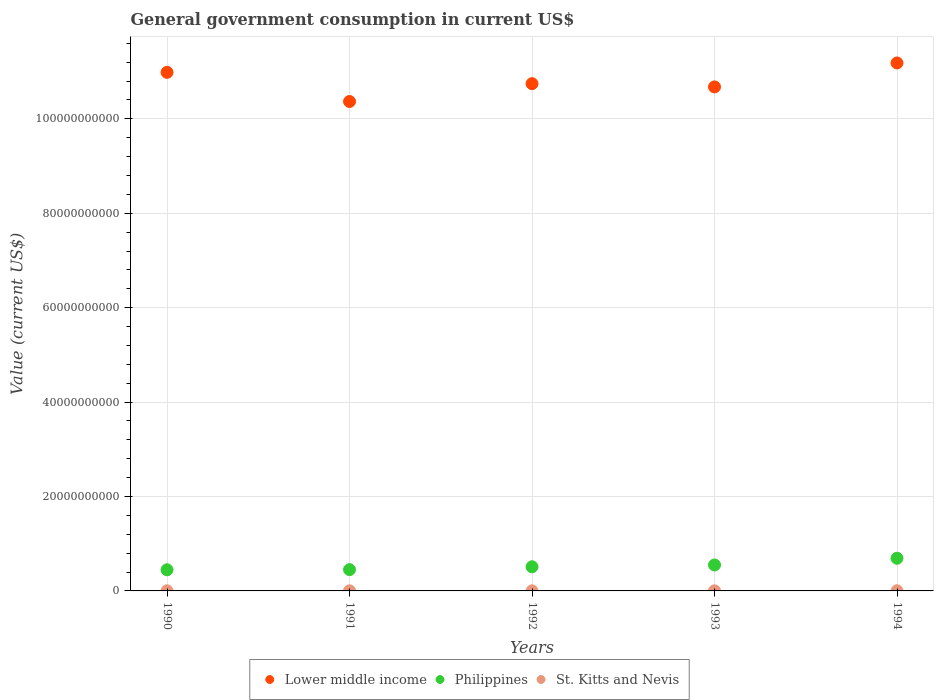How many different coloured dotlines are there?
Provide a short and direct response. 3. What is the government conusmption in Lower middle income in 1991?
Provide a short and direct response. 1.04e+11. Across all years, what is the maximum government conusmption in Lower middle income?
Provide a short and direct response. 1.12e+11. Across all years, what is the minimum government conusmption in Philippines?
Your answer should be very brief. 4.48e+09. In which year was the government conusmption in Philippines maximum?
Provide a short and direct response. 1994. In which year was the government conusmption in Philippines minimum?
Give a very brief answer. 1990. What is the total government conusmption in Lower middle income in the graph?
Make the answer very short. 5.40e+11. What is the difference between the government conusmption in Philippines in 1990 and that in 1994?
Your answer should be very brief. -2.44e+09. What is the difference between the government conusmption in St. Kitts and Nevis in 1993 and the government conusmption in Philippines in 1990?
Keep it short and to the point. -4.45e+09. What is the average government conusmption in Philippines per year?
Keep it short and to the point. 5.30e+09. In the year 1994, what is the difference between the government conusmption in St. Kitts and Nevis and government conusmption in Lower middle income?
Make the answer very short. -1.12e+11. What is the ratio of the government conusmption in Lower middle income in 1990 to that in 1994?
Provide a succinct answer. 0.98. Is the difference between the government conusmption in St. Kitts and Nevis in 1992 and 1994 greater than the difference between the government conusmption in Lower middle income in 1992 and 1994?
Keep it short and to the point. Yes. What is the difference between the highest and the second highest government conusmption in Lower middle income?
Keep it short and to the point. 1.99e+09. What is the difference between the highest and the lowest government conusmption in Lower middle income?
Offer a very short reply. 8.16e+09. In how many years, is the government conusmption in Lower middle income greater than the average government conusmption in Lower middle income taken over all years?
Your answer should be very brief. 2. Is it the case that in every year, the sum of the government conusmption in Philippines and government conusmption in Lower middle income  is greater than the government conusmption in St. Kitts and Nevis?
Ensure brevity in your answer.  Yes. Does the government conusmption in Lower middle income monotonically increase over the years?
Provide a succinct answer. No. Is the government conusmption in Lower middle income strictly less than the government conusmption in Philippines over the years?
Your response must be concise. No. How many years are there in the graph?
Your response must be concise. 5. What is the difference between two consecutive major ticks on the Y-axis?
Ensure brevity in your answer.  2.00e+1. Are the values on the major ticks of Y-axis written in scientific E-notation?
Keep it short and to the point. No. What is the title of the graph?
Give a very brief answer. General government consumption in current US$. What is the label or title of the X-axis?
Ensure brevity in your answer.  Years. What is the label or title of the Y-axis?
Give a very brief answer. Value (current US$). What is the Value (current US$) of Lower middle income in 1990?
Give a very brief answer. 1.10e+11. What is the Value (current US$) of Philippines in 1990?
Offer a very short reply. 4.48e+09. What is the Value (current US$) of St. Kitts and Nevis in 1990?
Give a very brief answer. 2.09e+07. What is the Value (current US$) of Lower middle income in 1991?
Your response must be concise. 1.04e+11. What is the Value (current US$) of Philippines in 1991?
Your response must be concise. 4.51e+09. What is the Value (current US$) of St. Kitts and Nevis in 1991?
Give a very brief answer. 2.08e+07. What is the Value (current US$) in Lower middle income in 1992?
Your answer should be very brief. 1.07e+11. What is the Value (current US$) of Philippines in 1992?
Give a very brief answer. 5.12e+09. What is the Value (current US$) of St. Kitts and Nevis in 1992?
Ensure brevity in your answer.  2.32e+07. What is the Value (current US$) in Lower middle income in 1993?
Make the answer very short. 1.07e+11. What is the Value (current US$) in Philippines in 1993?
Offer a very short reply. 5.50e+09. What is the Value (current US$) in St. Kitts and Nevis in 1993?
Give a very brief answer. 2.53e+07. What is the Value (current US$) in Lower middle income in 1994?
Your response must be concise. 1.12e+11. What is the Value (current US$) in Philippines in 1994?
Make the answer very short. 6.92e+09. What is the Value (current US$) in St. Kitts and Nevis in 1994?
Ensure brevity in your answer.  3.22e+07. Across all years, what is the maximum Value (current US$) of Lower middle income?
Give a very brief answer. 1.12e+11. Across all years, what is the maximum Value (current US$) of Philippines?
Give a very brief answer. 6.92e+09. Across all years, what is the maximum Value (current US$) in St. Kitts and Nevis?
Your answer should be compact. 3.22e+07. Across all years, what is the minimum Value (current US$) of Lower middle income?
Your response must be concise. 1.04e+11. Across all years, what is the minimum Value (current US$) of Philippines?
Your answer should be very brief. 4.48e+09. Across all years, what is the minimum Value (current US$) of St. Kitts and Nevis?
Give a very brief answer. 2.08e+07. What is the total Value (current US$) of Lower middle income in the graph?
Keep it short and to the point. 5.40e+11. What is the total Value (current US$) in Philippines in the graph?
Provide a short and direct response. 2.65e+1. What is the total Value (current US$) in St. Kitts and Nevis in the graph?
Your answer should be very brief. 1.22e+08. What is the difference between the Value (current US$) in Lower middle income in 1990 and that in 1991?
Offer a very short reply. 6.18e+09. What is the difference between the Value (current US$) of Philippines in 1990 and that in 1991?
Offer a very short reply. -3.12e+07. What is the difference between the Value (current US$) of St. Kitts and Nevis in 1990 and that in 1991?
Your answer should be compact. 1.52e+05. What is the difference between the Value (current US$) in Lower middle income in 1990 and that in 1992?
Provide a short and direct response. 2.40e+09. What is the difference between the Value (current US$) in Philippines in 1990 and that in 1992?
Your answer should be very brief. -6.39e+08. What is the difference between the Value (current US$) in St. Kitts and Nevis in 1990 and that in 1992?
Your answer should be compact. -2.34e+06. What is the difference between the Value (current US$) of Lower middle income in 1990 and that in 1993?
Your answer should be very brief. 3.09e+09. What is the difference between the Value (current US$) of Philippines in 1990 and that in 1993?
Your response must be concise. -1.02e+09. What is the difference between the Value (current US$) in St. Kitts and Nevis in 1990 and that in 1993?
Your answer should be very brief. -4.39e+06. What is the difference between the Value (current US$) in Lower middle income in 1990 and that in 1994?
Give a very brief answer. -1.99e+09. What is the difference between the Value (current US$) in Philippines in 1990 and that in 1994?
Provide a short and direct response. -2.44e+09. What is the difference between the Value (current US$) in St. Kitts and Nevis in 1990 and that in 1994?
Your answer should be compact. -1.13e+07. What is the difference between the Value (current US$) in Lower middle income in 1991 and that in 1992?
Offer a very short reply. -3.78e+09. What is the difference between the Value (current US$) of Philippines in 1991 and that in 1992?
Provide a short and direct response. -6.08e+08. What is the difference between the Value (current US$) of St. Kitts and Nevis in 1991 and that in 1992?
Offer a terse response. -2.49e+06. What is the difference between the Value (current US$) of Lower middle income in 1991 and that in 1993?
Ensure brevity in your answer.  -3.09e+09. What is the difference between the Value (current US$) in Philippines in 1991 and that in 1993?
Give a very brief answer. -9.88e+08. What is the difference between the Value (current US$) of St. Kitts and Nevis in 1991 and that in 1993?
Offer a terse response. -4.54e+06. What is the difference between the Value (current US$) in Lower middle income in 1991 and that in 1994?
Offer a very short reply. -8.16e+09. What is the difference between the Value (current US$) of Philippines in 1991 and that in 1994?
Your answer should be very brief. -2.41e+09. What is the difference between the Value (current US$) of St. Kitts and Nevis in 1991 and that in 1994?
Offer a terse response. -1.15e+07. What is the difference between the Value (current US$) of Lower middle income in 1992 and that in 1993?
Offer a terse response. 6.90e+08. What is the difference between the Value (current US$) in Philippines in 1992 and that in 1993?
Provide a short and direct response. -3.80e+08. What is the difference between the Value (current US$) of St. Kitts and Nevis in 1992 and that in 1993?
Give a very brief answer. -2.05e+06. What is the difference between the Value (current US$) in Lower middle income in 1992 and that in 1994?
Keep it short and to the point. -4.38e+09. What is the difference between the Value (current US$) in Philippines in 1992 and that in 1994?
Make the answer very short. -1.80e+09. What is the difference between the Value (current US$) in St. Kitts and Nevis in 1992 and that in 1994?
Provide a succinct answer. -8.97e+06. What is the difference between the Value (current US$) of Lower middle income in 1993 and that in 1994?
Your response must be concise. -5.07e+09. What is the difference between the Value (current US$) in Philippines in 1993 and that in 1994?
Provide a succinct answer. -1.42e+09. What is the difference between the Value (current US$) in St. Kitts and Nevis in 1993 and that in 1994?
Offer a very short reply. -6.92e+06. What is the difference between the Value (current US$) of Lower middle income in 1990 and the Value (current US$) of Philippines in 1991?
Make the answer very short. 1.05e+11. What is the difference between the Value (current US$) in Lower middle income in 1990 and the Value (current US$) in St. Kitts and Nevis in 1991?
Provide a succinct answer. 1.10e+11. What is the difference between the Value (current US$) of Philippines in 1990 and the Value (current US$) of St. Kitts and Nevis in 1991?
Make the answer very short. 4.46e+09. What is the difference between the Value (current US$) in Lower middle income in 1990 and the Value (current US$) in Philippines in 1992?
Keep it short and to the point. 1.05e+11. What is the difference between the Value (current US$) in Lower middle income in 1990 and the Value (current US$) in St. Kitts and Nevis in 1992?
Your answer should be compact. 1.10e+11. What is the difference between the Value (current US$) of Philippines in 1990 and the Value (current US$) of St. Kitts and Nevis in 1992?
Provide a short and direct response. 4.45e+09. What is the difference between the Value (current US$) in Lower middle income in 1990 and the Value (current US$) in Philippines in 1993?
Your response must be concise. 1.04e+11. What is the difference between the Value (current US$) of Lower middle income in 1990 and the Value (current US$) of St. Kitts and Nevis in 1993?
Give a very brief answer. 1.10e+11. What is the difference between the Value (current US$) in Philippines in 1990 and the Value (current US$) in St. Kitts and Nevis in 1993?
Give a very brief answer. 4.45e+09. What is the difference between the Value (current US$) of Lower middle income in 1990 and the Value (current US$) of Philippines in 1994?
Ensure brevity in your answer.  1.03e+11. What is the difference between the Value (current US$) in Lower middle income in 1990 and the Value (current US$) in St. Kitts and Nevis in 1994?
Your answer should be very brief. 1.10e+11. What is the difference between the Value (current US$) in Philippines in 1990 and the Value (current US$) in St. Kitts and Nevis in 1994?
Your answer should be compact. 4.44e+09. What is the difference between the Value (current US$) of Lower middle income in 1991 and the Value (current US$) of Philippines in 1992?
Make the answer very short. 9.86e+1. What is the difference between the Value (current US$) of Lower middle income in 1991 and the Value (current US$) of St. Kitts and Nevis in 1992?
Offer a very short reply. 1.04e+11. What is the difference between the Value (current US$) in Philippines in 1991 and the Value (current US$) in St. Kitts and Nevis in 1992?
Offer a very short reply. 4.49e+09. What is the difference between the Value (current US$) in Lower middle income in 1991 and the Value (current US$) in Philippines in 1993?
Provide a succinct answer. 9.82e+1. What is the difference between the Value (current US$) in Lower middle income in 1991 and the Value (current US$) in St. Kitts and Nevis in 1993?
Ensure brevity in your answer.  1.04e+11. What is the difference between the Value (current US$) in Philippines in 1991 and the Value (current US$) in St. Kitts and Nevis in 1993?
Provide a succinct answer. 4.48e+09. What is the difference between the Value (current US$) of Lower middle income in 1991 and the Value (current US$) of Philippines in 1994?
Provide a short and direct response. 9.67e+1. What is the difference between the Value (current US$) of Lower middle income in 1991 and the Value (current US$) of St. Kitts and Nevis in 1994?
Offer a very short reply. 1.04e+11. What is the difference between the Value (current US$) in Philippines in 1991 and the Value (current US$) in St. Kitts and Nevis in 1994?
Offer a very short reply. 4.48e+09. What is the difference between the Value (current US$) of Lower middle income in 1992 and the Value (current US$) of Philippines in 1993?
Provide a succinct answer. 1.02e+11. What is the difference between the Value (current US$) of Lower middle income in 1992 and the Value (current US$) of St. Kitts and Nevis in 1993?
Offer a terse response. 1.07e+11. What is the difference between the Value (current US$) in Philippines in 1992 and the Value (current US$) in St. Kitts and Nevis in 1993?
Offer a very short reply. 5.09e+09. What is the difference between the Value (current US$) of Lower middle income in 1992 and the Value (current US$) of Philippines in 1994?
Your answer should be compact. 1.01e+11. What is the difference between the Value (current US$) in Lower middle income in 1992 and the Value (current US$) in St. Kitts and Nevis in 1994?
Ensure brevity in your answer.  1.07e+11. What is the difference between the Value (current US$) in Philippines in 1992 and the Value (current US$) in St. Kitts and Nevis in 1994?
Provide a short and direct response. 5.08e+09. What is the difference between the Value (current US$) in Lower middle income in 1993 and the Value (current US$) in Philippines in 1994?
Provide a short and direct response. 9.98e+1. What is the difference between the Value (current US$) of Lower middle income in 1993 and the Value (current US$) of St. Kitts and Nevis in 1994?
Your answer should be very brief. 1.07e+11. What is the difference between the Value (current US$) of Philippines in 1993 and the Value (current US$) of St. Kitts and Nevis in 1994?
Provide a succinct answer. 5.46e+09. What is the average Value (current US$) of Lower middle income per year?
Your response must be concise. 1.08e+11. What is the average Value (current US$) of Philippines per year?
Offer a very short reply. 5.30e+09. What is the average Value (current US$) in St. Kitts and Nevis per year?
Provide a short and direct response. 2.45e+07. In the year 1990, what is the difference between the Value (current US$) in Lower middle income and Value (current US$) in Philippines?
Ensure brevity in your answer.  1.05e+11. In the year 1990, what is the difference between the Value (current US$) of Lower middle income and Value (current US$) of St. Kitts and Nevis?
Keep it short and to the point. 1.10e+11. In the year 1990, what is the difference between the Value (current US$) in Philippines and Value (current US$) in St. Kitts and Nevis?
Your answer should be very brief. 4.46e+09. In the year 1991, what is the difference between the Value (current US$) of Lower middle income and Value (current US$) of Philippines?
Give a very brief answer. 9.92e+1. In the year 1991, what is the difference between the Value (current US$) in Lower middle income and Value (current US$) in St. Kitts and Nevis?
Provide a succinct answer. 1.04e+11. In the year 1991, what is the difference between the Value (current US$) in Philippines and Value (current US$) in St. Kitts and Nevis?
Ensure brevity in your answer.  4.49e+09. In the year 1992, what is the difference between the Value (current US$) of Lower middle income and Value (current US$) of Philippines?
Offer a very short reply. 1.02e+11. In the year 1992, what is the difference between the Value (current US$) of Lower middle income and Value (current US$) of St. Kitts and Nevis?
Your answer should be compact. 1.07e+11. In the year 1992, what is the difference between the Value (current US$) in Philippines and Value (current US$) in St. Kitts and Nevis?
Your response must be concise. 5.09e+09. In the year 1993, what is the difference between the Value (current US$) of Lower middle income and Value (current US$) of Philippines?
Keep it short and to the point. 1.01e+11. In the year 1993, what is the difference between the Value (current US$) of Lower middle income and Value (current US$) of St. Kitts and Nevis?
Provide a short and direct response. 1.07e+11. In the year 1993, what is the difference between the Value (current US$) of Philippines and Value (current US$) of St. Kitts and Nevis?
Make the answer very short. 5.47e+09. In the year 1994, what is the difference between the Value (current US$) of Lower middle income and Value (current US$) of Philippines?
Offer a terse response. 1.05e+11. In the year 1994, what is the difference between the Value (current US$) in Lower middle income and Value (current US$) in St. Kitts and Nevis?
Give a very brief answer. 1.12e+11. In the year 1994, what is the difference between the Value (current US$) of Philippines and Value (current US$) of St. Kitts and Nevis?
Keep it short and to the point. 6.89e+09. What is the ratio of the Value (current US$) of Lower middle income in 1990 to that in 1991?
Offer a very short reply. 1.06. What is the ratio of the Value (current US$) of Philippines in 1990 to that in 1991?
Your answer should be compact. 0.99. What is the ratio of the Value (current US$) in St. Kitts and Nevis in 1990 to that in 1991?
Your answer should be compact. 1.01. What is the ratio of the Value (current US$) in Lower middle income in 1990 to that in 1992?
Your answer should be very brief. 1.02. What is the ratio of the Value (current US$) of Philippines in 1990 to that in 1992?
Keep it short and to the point. 0.88. What is the ratio of the Value (current US$) in St. Kitts and Nevis in 1990 to that in 1992?
Offer a terse response. 0.9. What is the ratio of the Value (current US$) of Lower middle income in 1990 to that in 1993?
Provide a succinct answer. 1.03. What is the ratio of the Value (current US$) of Philippines in 1990 to that in 1993?
Offer a very short reply. 0.81. What is the ratio of the Value (current US$) in St. Kitts and Nevis in 1990 to that in 1993?
Keep it short and to the point. 0.83. What is the ratio of the Value (current US$) in Lower middle income in 1990 to that in 1994?
Your answer should be very brief. 0.98. What is the ratio of the Value (current US$) of Philippines in 1990 to that in 1994?
Your answer should be compact. 0.65. What is the ratio of the Value (current US$) in St. Kitts and Nevis in 1990 to that in 1994?
Make the answer very short. 0.65. What is the ratio of the Value (current US$) of Lower middle income in 1991 to that in 1992?
Ensure brevity in your answer.  0.96. What is the ratio of the Value (current US$) of Philippines in 1991 to that in 1992?
Provide a succinct answer. 0.88. What is the ratio of the Value (current US$) of St. Kitts and Nevis in 1991 to that in 1992?
Give a very brief answer. 0.89. What is the ratio of the Value (current US$) of Philippines in 1991 to that in 1993?
Provide a succinct answer. 0.82. What is the ratio of the Value (current US$) of St. Kitts and Nevis in 1991 to that in 1993?
Make the answer very short. 0.82. What is the ratio of the Value (current US$) in Lower middle income in 1991 to that in 1994?
Give a very brief answer. 0.93. What is the ratio of the Value (current US$) in Philippines in 1991 to that in 1994?
Give a very brief answer. 0.65. What is the ratio of the Value (current US$) of St. Kitts and Nevis in 1991 to that in 1994?
Make the answer very short. 0.64. What is the ratio of the Value (current US$) of Lower middle income in 1992 to that in 1993?
Give a very brief answer. 1.01. What is the ratio of the Value (current US$) in Philippines in 1992 to that in 1993?
Your answer should be compact. 0.93. What is the ratio of the Value (current US$) of St. Kitts and Nevis in 1992 to that in 1993?
Keep it short and to the point. 0.92. What is the ratio of the Value (current US$) in Lower middle income in 1992 to that in 1994?
Your answer should be compact. 0.96. What is the ratio of the Value (current US$) in Philippines in 1992 to that in 1994?
Ensure brevity in your answer.  0.74. What is the ratio of the Value (current US$) of St. Kitts and Nevis in 1992 to that in 1994?
Your response must be concise. 0.72. What is the ratio of the Value (current US$) in Lower middle income in 1993 to that in 1994?
Give a very brief answer. 0.95. What is the ratio of the Value (current US$) of Philippines in 1993 to that in 1994?
Keep it short and to the point. 0.79. What is the ratio of the Value (current US$) in St. Kitts and Nevis in 1993 to that in 1994?
Offer a terse response. 0.79. What is the difference between the highest and the second highest Value (current US$) in Lower middle income?
Make the answer very short. 1.99e+09. What is the difference between the highest and the second highest Value (current US$) of Philippines?
Your response must be concise. 1.42e+09. What is the difference between the highest and the second highest Value (current US$) in St. Kitts and Nevis?
Ensure brevity in your answer.  6.92e+06. What is the difference between the highest and the lowest Value (current US$) of Lower middle income?
Your answer should be compact. 8.16e+09. What is the difference between the highest and the lowest Value (current US$) in Philippines?
Keep it short and to the point. 2.44e+09. What is the difference between the highest and the lowest Value (current US$) in St. Kitts and Nevis?
Offer a terse response. 1.15e+07. 